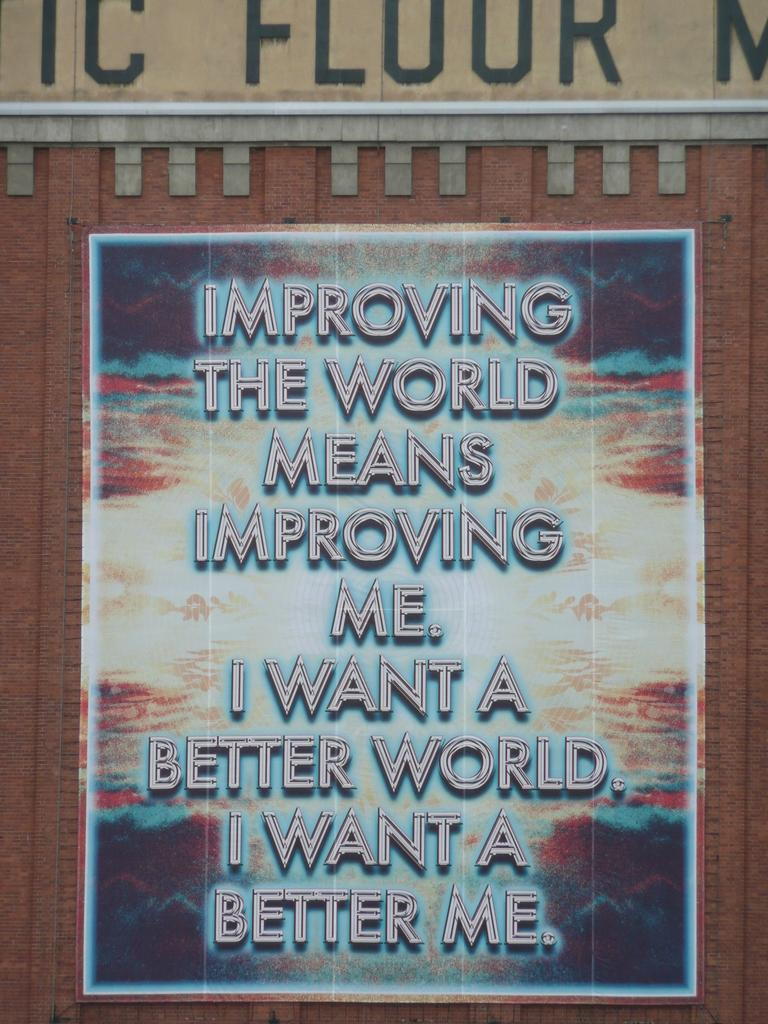<image>
Relay a brief, clear account of the picture shown. A poster displays the text 'IMPROVING THE WORLD MEANS IMPROVING ME'. 